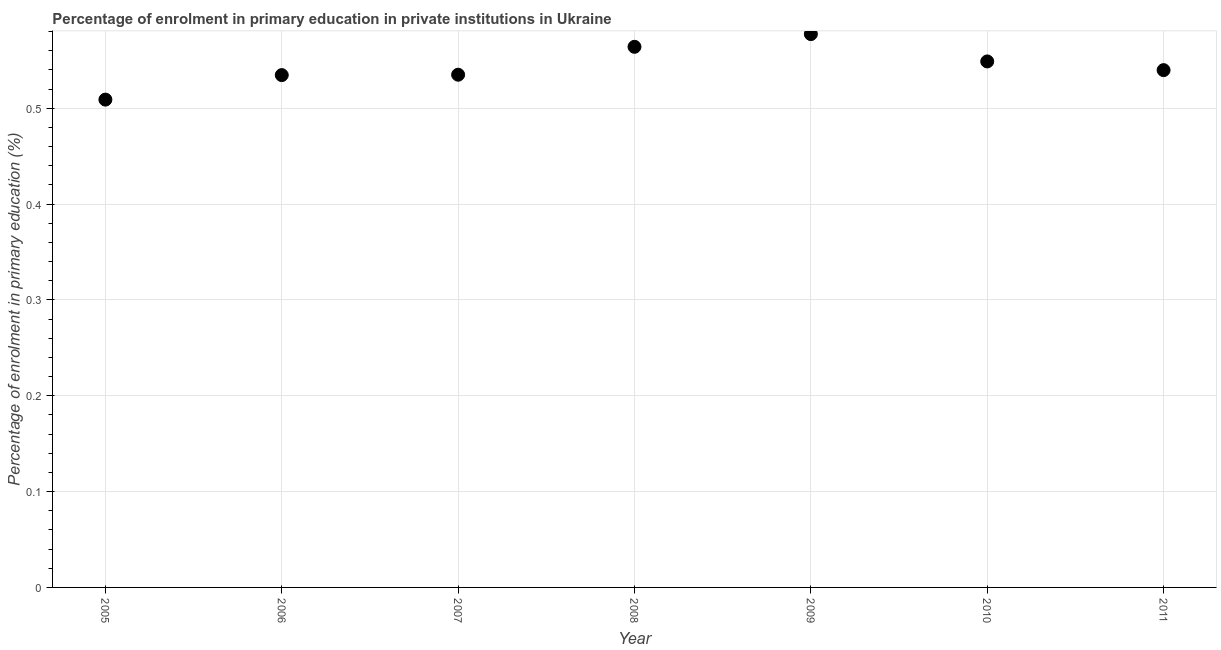What is the enrolment percentage in primary education in 2006?
Give a very brief answer. 0.53. Across all years, what is the maximum enrolment percentage in primary education?
Provide a succinct answer. 0.58. Across all years, what is the minimum enrolment percentage in primary education?
Provide a short and direct response. 0.51. In which year was the enrolment percentage in primary education maximum?
Offer a terse response. 2009. What is the sum of the enrolment percentage in primary education?
Offer a terse response. 3.81. What is the difference between the enrolment percentage in primary education in 2005 and 2010?
Your response must be concise. -0.04. What is the average enrolment percentage in primary education per year?
Offer a terse response. 0.54. What is the median enrolment percentage in primary education?
Your response must be concise. 0.54. In how many years, is the enrolment percentage in primary education greater than 0.04 %?
Your response must be concise. 7. What is the ratio of the enrolment percentage in primary education in 2006 to that in 2007?
Ensure brevity in your answer.  1. Is the difference between the enrolment percentage in primary education in 2007 and 2010 greater than the difference between any two years?
Your answer should be compact. No. What is the difference between the highest and the second highest enrolment percentage in primary education?
Offer a terse response. 0.01. What is the difference between the highest and the lowest enrolment percentage in primary education?
Ensure brevity in your answer.  0.07. Does the enrolment percentage in primary education monotonically increase over the years?
Ensure brevity in your answer.  No. How many years are there in the graph?
Your answer should be very brief. 7. What is the difference between two consecutive major ticks on the Y-axis?
Provide a succinct answer. 0.1. Are the values on the major ticks of Y-axis written in scientific E-notation?
Your answer should be compact. No. Does the graph contain any zero values?
Provide a short and direct response. No. What is the title of the graph?
Provide a short and direct response. Percentage of enrolment in primary education in private institutions in Ukraine. What is the label or title of the X-axis?
Offer a very short reply. Year. What is the label or title of the Y-axis?
Provide a short and direct response. Percentage of enrolment in primary education (%). What is the Percentage of enrolment in primary education (%) in 2005?
Offer a terse response. 0.51. What is the Percentage of enrolment in primary education (%) in 2006?
Offer a very short reply. 0.53. What is the Percentage of enrolment in primary education (%) in 2007?
Offer a terse response. 0.53. What is the Percentage of enrolment in primary education (%) in 2008?
Keep it short and to the point. 0.56. What is the Percentage of enrolment in primary education (%) in 2009?
Provide a succinct answer. 0.58. What is the Percentage of enrolment in primary education (%) in 2010?
Provide a short and direct response. 0.55. What is the Percentage of enrolment in primary education (%) in 2011?
Offer a terse response. 0.54. What is the difference between the Percentage of enrolment in primary education (%) in 2005 and 2006?
Offer a very short reply. -0.03. What is the difference between the Percentage of enrolment in primary education (%) in 2005 and 2007?
Make the answer very short. -0.03. What is the difference between the Percentage of enrolment in primary education (%) in 2005 and 2008?
Ensure brevity in your answer.  -0.06. What is the difference between the Percentage of enrolment in primary education (%) in 2005 and 2009?
Offer a terse response. -0.07. What is the difference between the Percentage of enrolment in primary education (%) in 2005 and 2010?
Your response must be concise. -0.04. What is the difference between the Percentage of enrolment in primary education (%) in 2005 and 2011?
Your response must be concise. -0.03. What is the difference between the Percentage of enrolment in primary education (%) in 2006 and 2007?
Keep it short and to the point. -0. What is the difference between the Percentage of enrolment in primary education (%) in 2006 and 2008?
Offer a very short reply. -0.03. What is the difference between the Percentage of enrolment in primary education (%) in 2006 and 2009?
Make the answer very short. -0.04. What is the difference between the Percentage of enrolment in primary education (%) in 2006 and 2010?
Offer a very short reply. -0.01. What is the difference between the Percentage of enrolment in primary education (%) in 2006 and 2011?
Make the answer very short. -0.01. What is the difference between the Percentage of enrolment in primary education (%) in 2007 and 2008?
Your answer should be compact. -0.03. What is the difference between the Percentage of enrolment in primary education (%) in 2007 and 2009?
Your answer should be very brief. -0.04. What is the difference between the Percentage of enrolment in primary education (%) in 2007 and 2010?
Your answer should be compact. -0.01. What is the difference between the Percentage of enrolment in primary education (%) in 2007 and 2011?
Give a very brief answer. -0. What is the difference between the Percentage of enrolment in primary education (%) in 2008 and 2009?
Provide a succinct answer. -0.01. What is the difference between the Percentage of enrolment in primary education (%) in 2008 and 2010?
Ensure brevity in your answer.  0.02. What is the difference between the Percentage of enrolment in primary education (%) in 2008 and 2011?
Keep it short and to the point. 0.02. What is the difference between the Percentage of enrolment in primary education (%) in 2009 and 2010?
Your answer should be compact. 0.03. What is the difference between the Percentage of enrolment in primary education (%) in 2009 and 2011?
Keep it short and to the point. 0.04. What is the difference between the Percentage of enrolment in primary education (%) in 2010 and 2011?
Your response must be concise. 0.01. What is the ratio of the Percentage of enrolment in primary education (%) in 2005 to that in 2006?
Your answer should be very brief. 0.95. What is the ratio of the Percentage of enrolment in primary education (%) in 2005 to that in 2007?
Make the answer very short. 0.95. What is the ratio of the Percentage of enrolment in primary education (%) in 2005 to that in 2008?
Ensure brevity in your answer.  0.9. What is the ratio of the Percentage of enrolment in primary education (%) in 2005 to that in 2009?
Offer a very short reply. 0.88. What is the ratio of the Percentage of enrolment in primary education (%) in 2005 to that in 2010?
Your response must be concise. 0.93. What is the ratio of the Percentage of enrolment in primary education (%) in 2005 to that in 2011?
Make the answer very short. 0.94. What is the ratio of the Percentage of enrolment in primary education (%) in 2006 to that in 2008?
Your answer should be very brief. 0.95. What is the ratio of the Percentage of enrolment in primary education (%) in 2006 to that in 2009?
Give a very brief answer. 0.93. What is the ratio of the Percentage of enrolment in primary education (%) in 2006 to that in 2011?
Give a very brief answer. 0.99. What is the ratio of the Percentage of enrolment in primary education (%) in 2007 to that in 2008?
Your response must be concise. 0.95. What is the ratio of the Percentage of enrolment in primary education (%) in 2007 to that in 2009?
Your answer should be very brief. 0.93. What is the ratio of the Percentage of enrolment in primary education (%) in 2007 to that in 2011?
Give a very brief answer. 0.99. What is the ratio of the Percentage of enrolment in primary education (%) in 2008 to that in 2009?
Offer a terse response. 0.98. What is the ratio of the Percentage of enrolment in primary education (%) in 2008 to that in 2010?
Your answer should be compact. 1.03. What is the ratio of the Percentage of enrolment in primary education (%) in 2008 to that in 2011?
Ensure brevity in your answer.  1.04. What is the ratio of the Percentage of enrolment in primary education (%) in 2009 to that in 2010?
Keep it short and to the point. 1.05. What is the ratio of the Percentage of enrolment in primary education (%) in 2009 to that in 2011?
Your response must be concise. 1.07. What is the ratio of the Percentage of enrolment in primary education (%) in 2010 to that in 2011?
Ensure brevity in your answer.  1.02. 